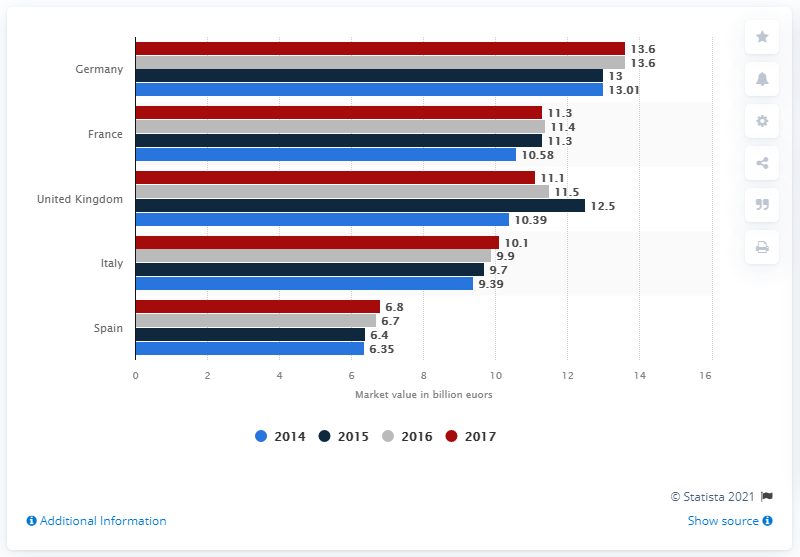Outline some significant characteristics in this image. The sum total of all the countries in the year 2015 is 52.9. In 2017, Germany was the European country that held the highest ranking. In 2017, the market value of the French cosmetics market was 11.3 billion euros. In 2017, Germany was the leading country in the European cosmetic market. In 2017, the value of the British cosmetics market was 11.1 billion pounds. 